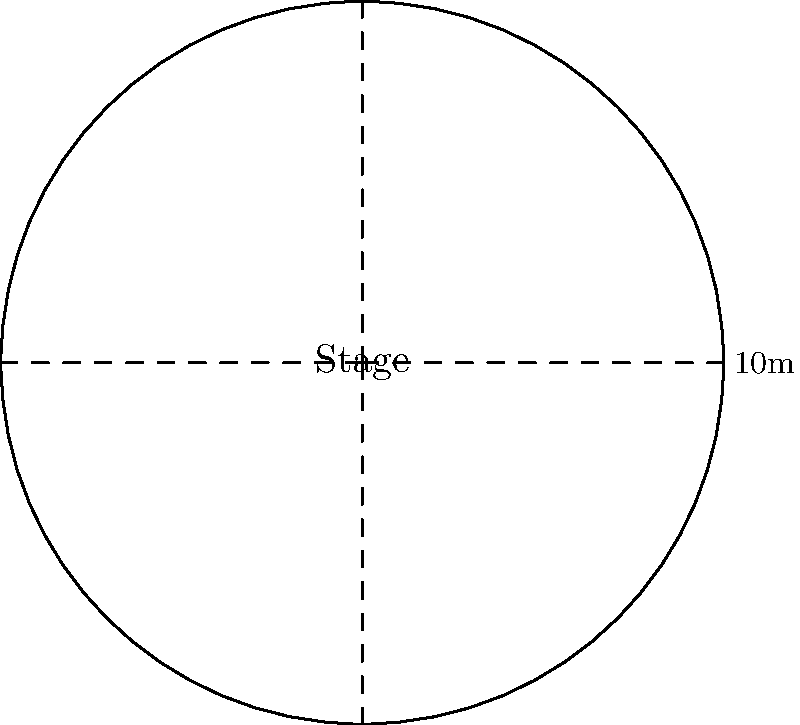A circular stage for an up-and-coming artist's performance has a diameter of 10 meters. The venue manager wants to maximize audience capacity by arranging concentric circles of standing room around the stage, with each circle being 1 meter wide. If each person requires 0.5 square meters of standing space, what is the maximum number of audience members that can fit in the first three circles surrounding the stage? Let's approach this step-by-step:

1) The stage has a diameter of 10m, so its radius is 5m.

2) We need to calculate the areas of three concentric rings around the stage:
   - First ring: outer radius 6m, inner radius 5m
   - Second ring: outer radius 7m, inner radius 6m
   - Third ring: outer radius 8m, inner radius 7m

3) The area of each ring can be calculated using the formula:
   $A = \pi(R^2 - r^2)$, where $R$ is the outer radius and $r$ is the inner radius.

4) Calculating the areas:
   - First ring: $A_1 = \pi(6^2 - 5^2) = 11\pi$ m²
   - Second ring: $A_2 = \pi(7^2 - 6^2) = 13\pi$ m²
   - Third ring: $A_3 = \pi(8^2 - 7^2) = 15\pi$ m²

5) Total area available for the audience:
   $A_{total} = A_1 + A_2 + A_3 = (11 + 13 + 15)\pi = 39\pi$ m²

6) Each person requires 0.5 m², so the number of people that can fit is:
   $N = \frac{A_{total}}{0.5} = \frac{39\pi}{0.5} = 78\pi$

7) Since we can't have a fractional number of people, we round down to the nearest whole number.
Answer: 245 people 